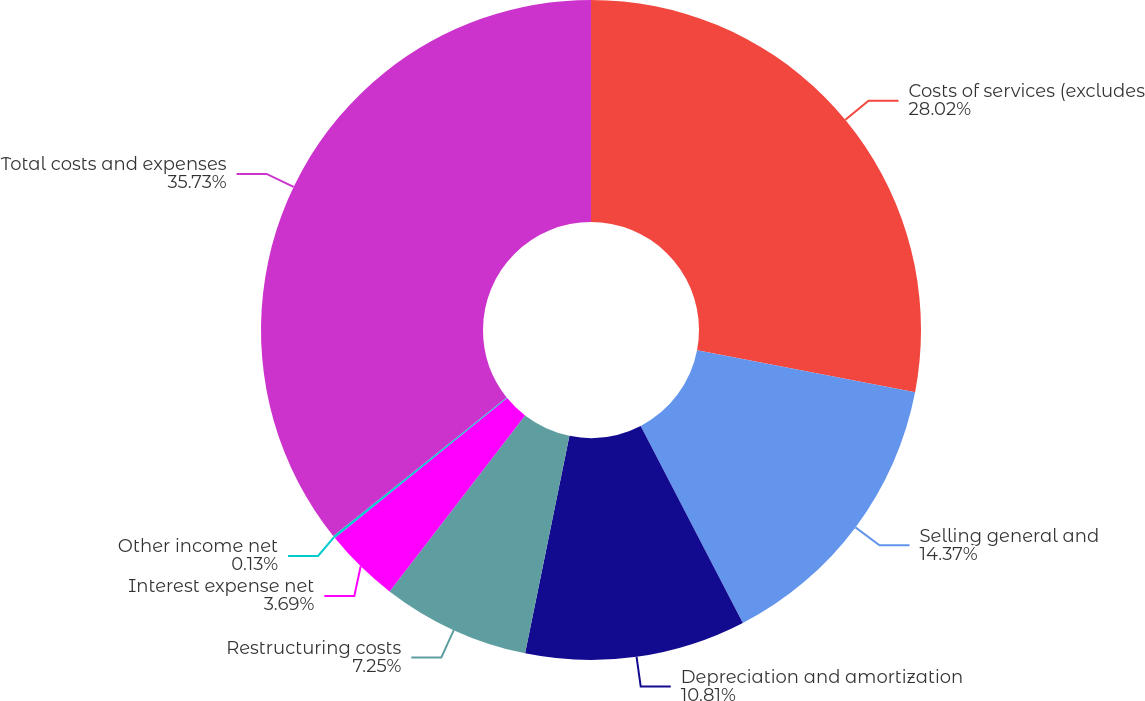Convert chart. <chart><loc_0><loc_0><loc_500><loc_500><pie_chart><fcel>Costs of services (excludes<fcel>Selling general and<fcel>Depreciation and amortization<fcel>Restructuring costs<fcel>Interest expense net<fcel>Other income net<fcel>Total costs and expenses<nl><fcel>28.02%<fcel>14.37%<fcel>10.81%<fcel>7.25%<fcel>3.69%<fcel>0.13%<fcel>35.73%<nl></chart> 